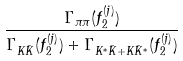Convert formula to latex. <formula><loc_0><loc_0><loc_500><loc_500>\frac { \Gamma _ { \pi \pi } ( f _ { 2 } ^ { ( j ) } ) } { \Gamma _ { K \bar { K } } ( f _ { 2 } ^ { ( j ) } ) + \Gamma _ { K ^ { * } \bar { K } + K \bar { K } ^ { * } } ( f _ { 2 } ^ { ( j ) } ) }</formula> 